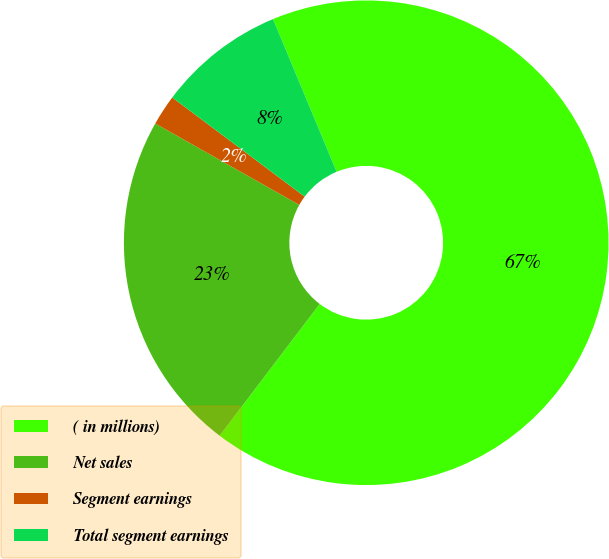Convert chart to OTSL. <chart><loc_0><loc_0><loc_500><loc_500><pie_chart><fcel>( in millions)<fcel>Net sales<fcel>Segment earnings<fcel>Total segment earnings<nl><fcel>66.62%<fcel>22.85%<fcel>2.04%<fcel>8.49%<nl></chart> 